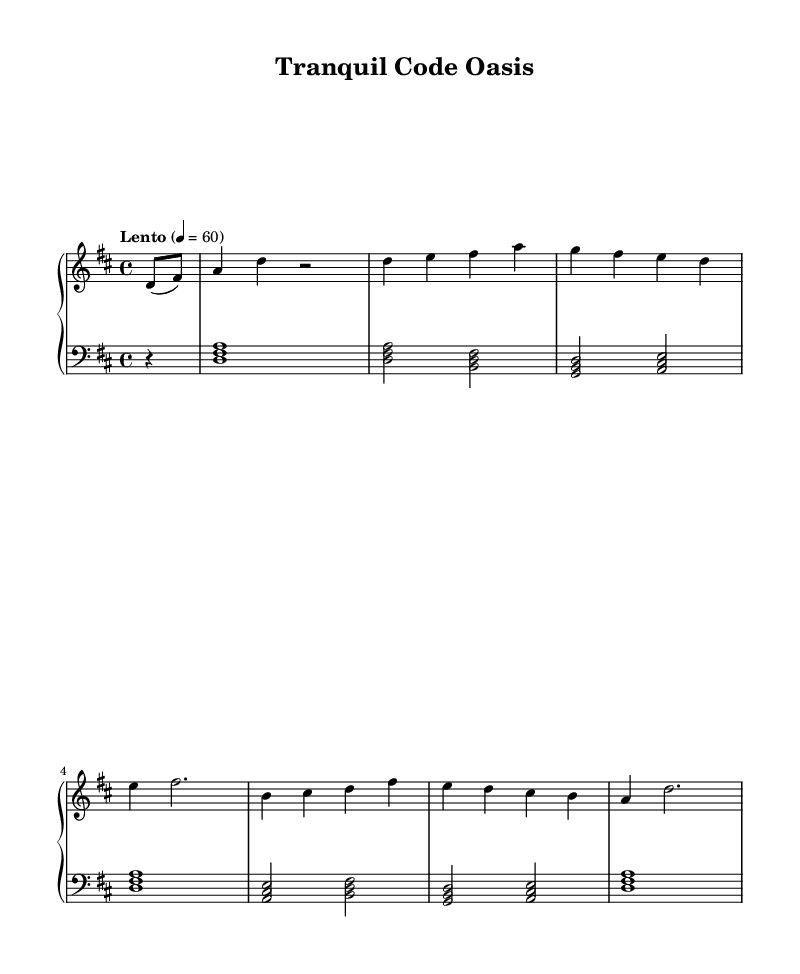What is the key signature of this music? The key signature shown at the beginning of the piece is "two sharps," which corresponds to the D major key.
Answer: D major What is the time signature indicated in the sheet music? The time signature appears at the beginning of the music and is written as "4/4," which means there are four beats in each measure and a quarter note receives one beat.
Answer: 4/4 What is the tempo marking for this piece? The tempo marking is "Lento," which indicates a slow pace for the piece, specifically a speed of 60 beats per minute as noted.
Answer: Lento How many measures are in the main theme of the music? Counting the measures that contain distinct melodic phrases in the main theme section, there are four measures explicitly grouped together.
Answer: 4 Which intervals do the left hand chords typically utilize? The left-hand chords include three-note chords positioned primarily in intervals of thirds, creating a harmonious base typical for ambient music.
Answer: Thirds What is the relationship between the right-hand and left-hand melodies in this piece? The right hand often plays the melody while the left hand supports it harmonically, creating a rich texture characteristic of meditative music.
Answer: Complementary 